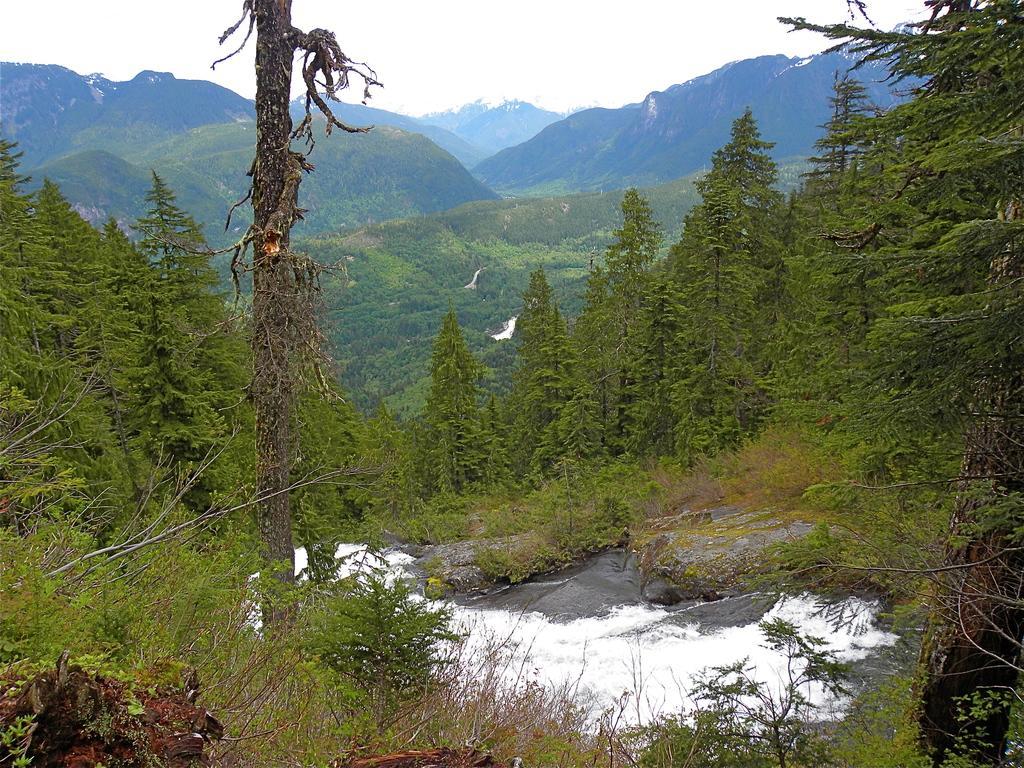Please provide a concise description of this image. In this image, we can see some water, plants and trees. We can also see some hills and the sky. We can also see some white colored objects. 